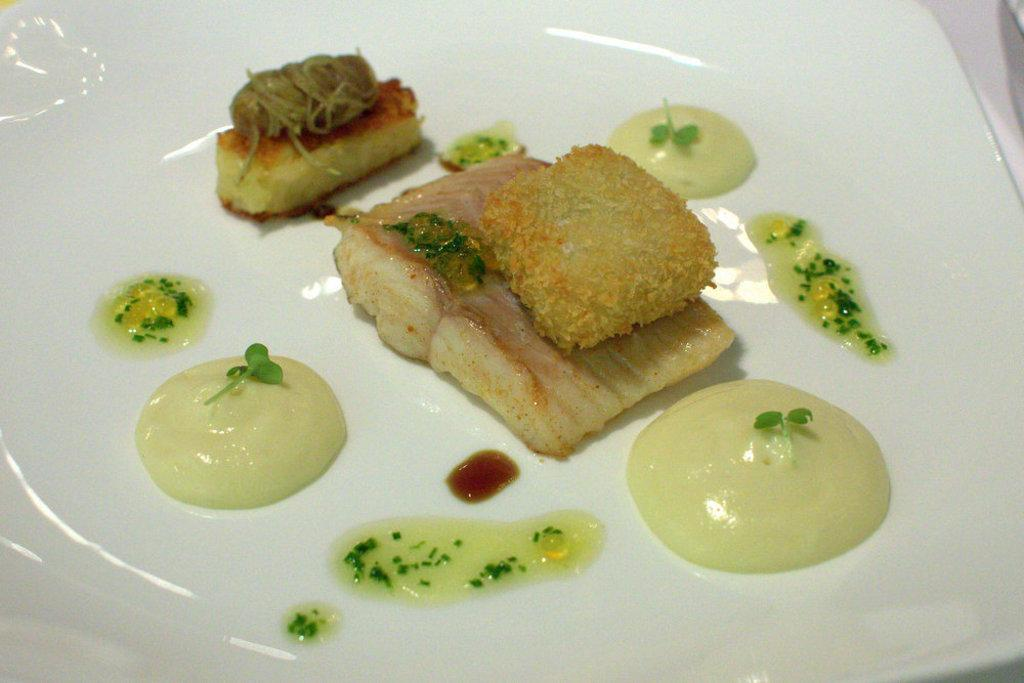What object is present in the image that might be used for serving or holding food? There is a plate in the image that can be used for serving or holding food. What is on the plate in the image? There are food items on the plate in the image. Can you describe anything else visible in the image? There is a cloth visible at the side of the image. What type of farm animals can be seen grazing on the patch in the image? There is no farm or patch present in the image; it only features a plate with food items and a cloth. 